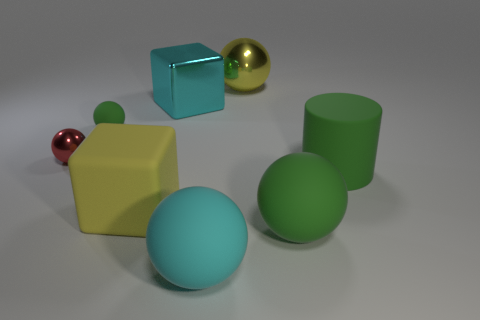Are there the same number of yellow balls in front of the tiny red metal object and large matte spheres in front of the large green sphere?
Keep it short and to the point. No. What material is the large cyan ball?
Provide a short and direct response. Rubber. There is a green sphere that is on the left side of the large cyan rubber thing; what is its material?
Give a very brief answer. Rubber. Are there more cyan rubber objects in front of the cyan metallic object than metallic cubes?
Keep it short and to the point. No. There is a cube that is in front of the green rubber cylinder that is right of the metallic cube; is there a matte sphere that is in front of it?
Offer a very short reply. Yes. There is a rubber cylinder; are there any tiny green things behind it?
Give a very brief answer. Yes. How many tiny shiny objects are the same color as the big rubber block?
Your answer should be compact. 0. The cylinder that is the same material as the large green ball is what size?
Your response must be concise. Large. There is a sphere behind the cube behind the big green thing that is to the right of the large green sphere; what is its size?
Provide a succinct answer. Large. What size is the green thing behind the red metallic sphere?
Your answer should be very brief. Small. 